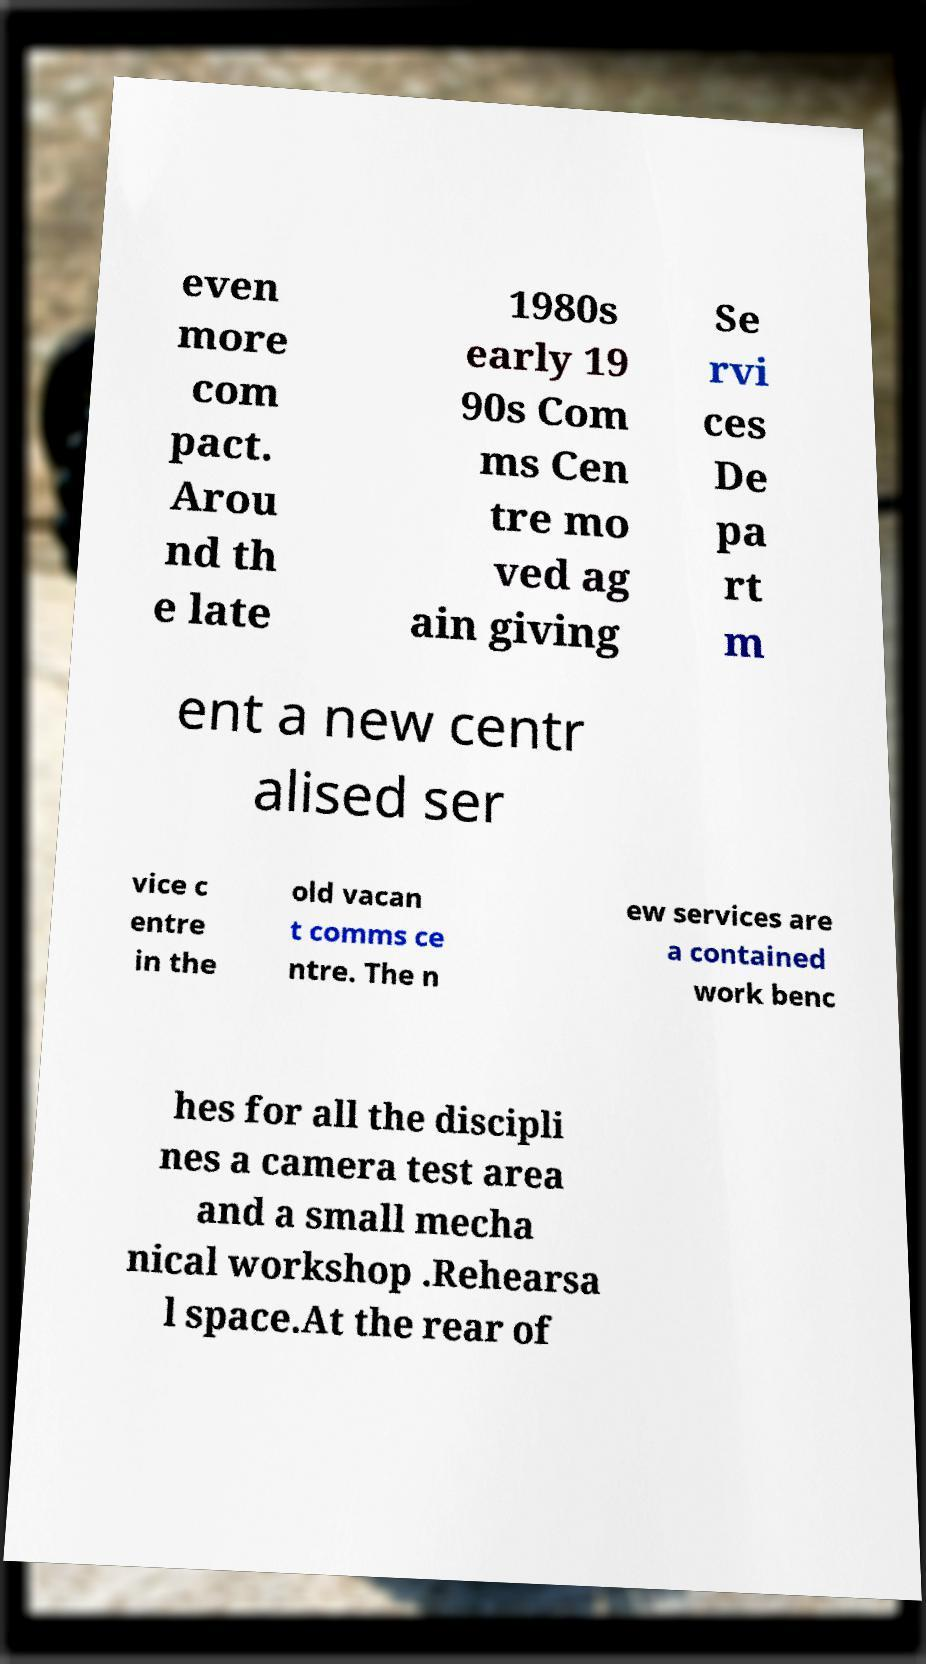For documentation purposes, I need the text within this image transcribed. Could you provide that? even more com pact. Arou nd th e late 1980s early 19 90s Com ms Cen tre mo ved ag ain giving Se rvi ces De pa rt m ent a new centr alised ser vice c entre in the old vacan t comms ce ntre. The n ew services are a contained work benc hes for all the discipli nes a camera test area and a small mecha nical workshop .Rehearsa l space.At the rear of 